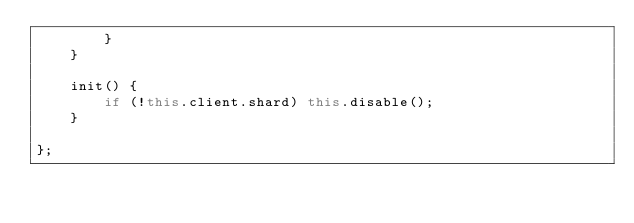Convert code to text. <code><loc_0><loc_0><loc_500><loc_500><_JavaScript_>		}
	}

	init() {
		if (!this.client.shard) this.disable();
	}

};
</code> 